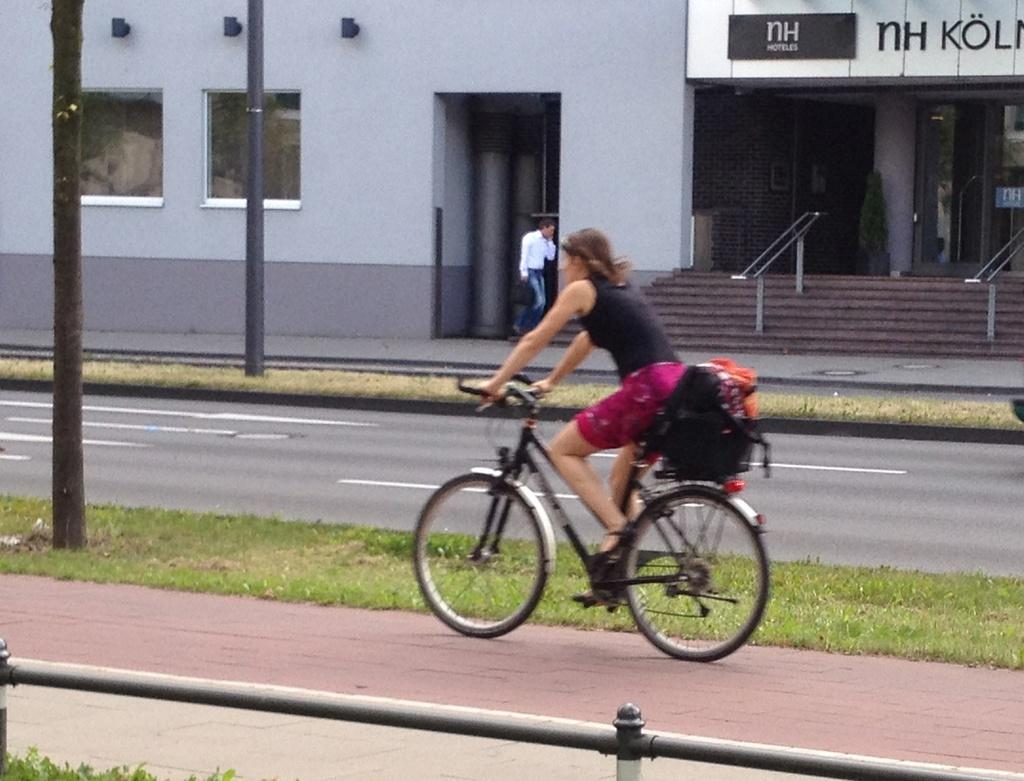What is the woman in the image doing? The woman is riding a bicycle in the image. What is the man in the image doing? The man is walking on the sidewalk in the image. What type of establishment can be seen in the image? There is a store in the image. What type of structure is present in the image? There is a building in the image. What object can be seen standing upright in the image? There is a pole in the image. How many trucks are parked in front of the store in the image? There are no trucks present in the image; it only features a woman riding a bicycle, a man walking on the sidewalk, a store, a building, and a pole. 